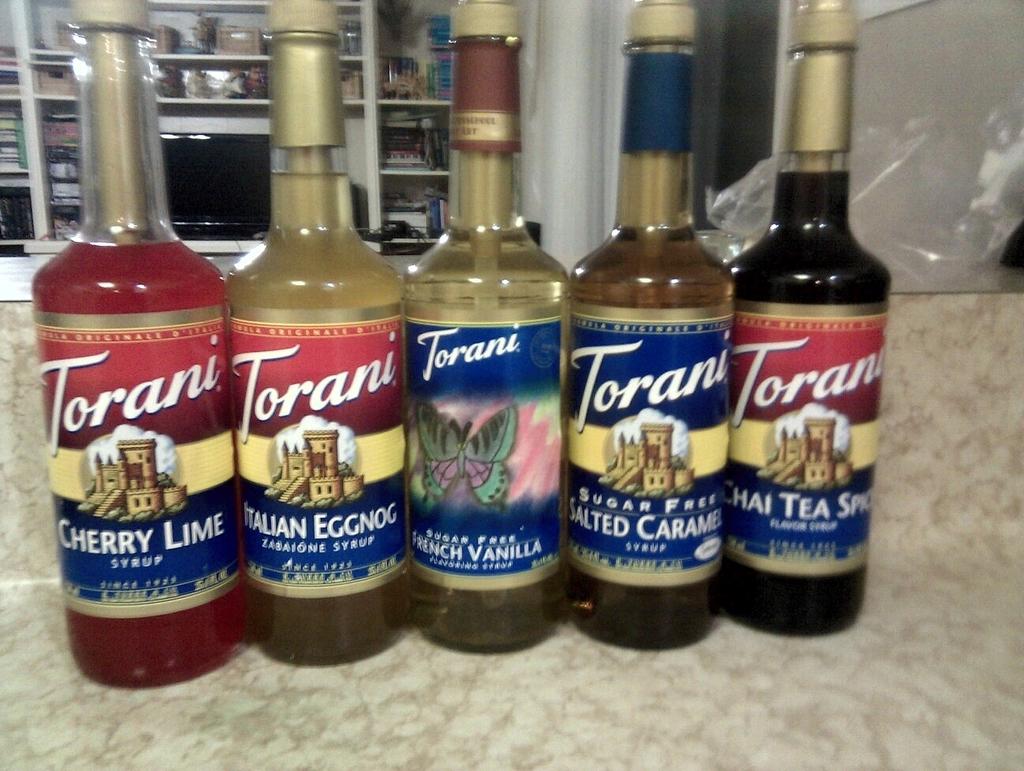What flavors are these syrups?
Your answer should be compact. Cherry lime, italian eggnog, french vanilla, salted caramel, chai tea spice. What brand are the syrups?
Provide a succinct answer. Torani. 